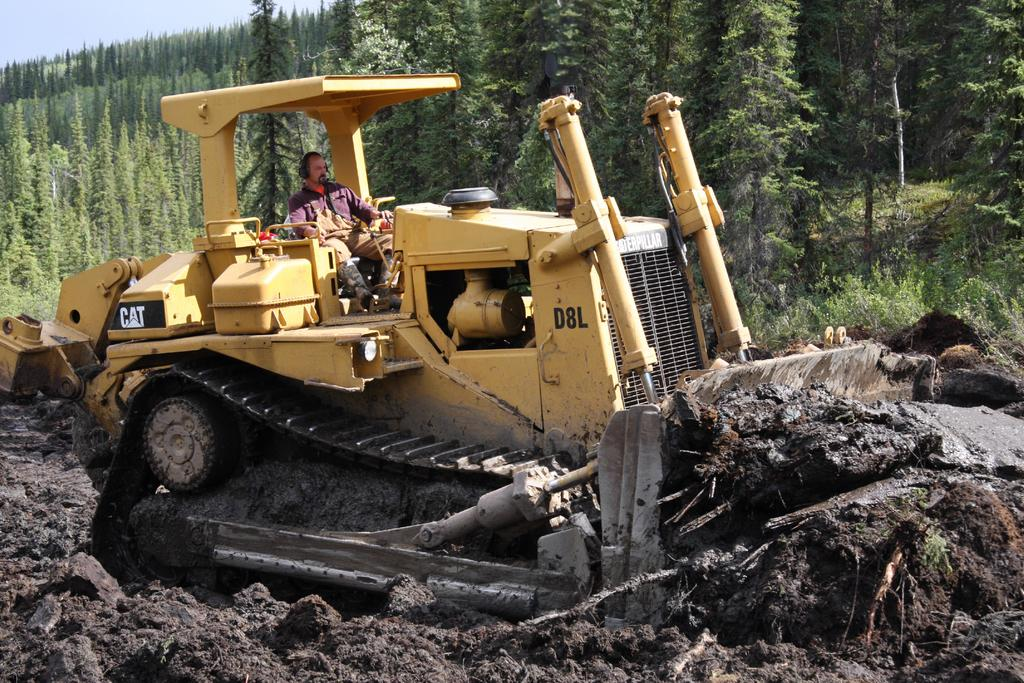What is the man doing in the image? The man is riding a bulldozer in the image. What color is the bulldozer? The bulldozer is yellow. What can be seen at the bottom of the image? There is mud visible at the bottom of the image. What is visible in the background of the image? There are trees in the background of the image. What type of selection is the man making in the downtown area in the image? There is no mention of a selection or a downtown area in the image; it features a man riding a yellow bulldozer in a setting with mud and trees. 